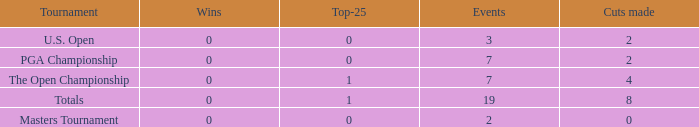What is the lowest Top-25 that has 3 Events and Wins greater than 0? None. 